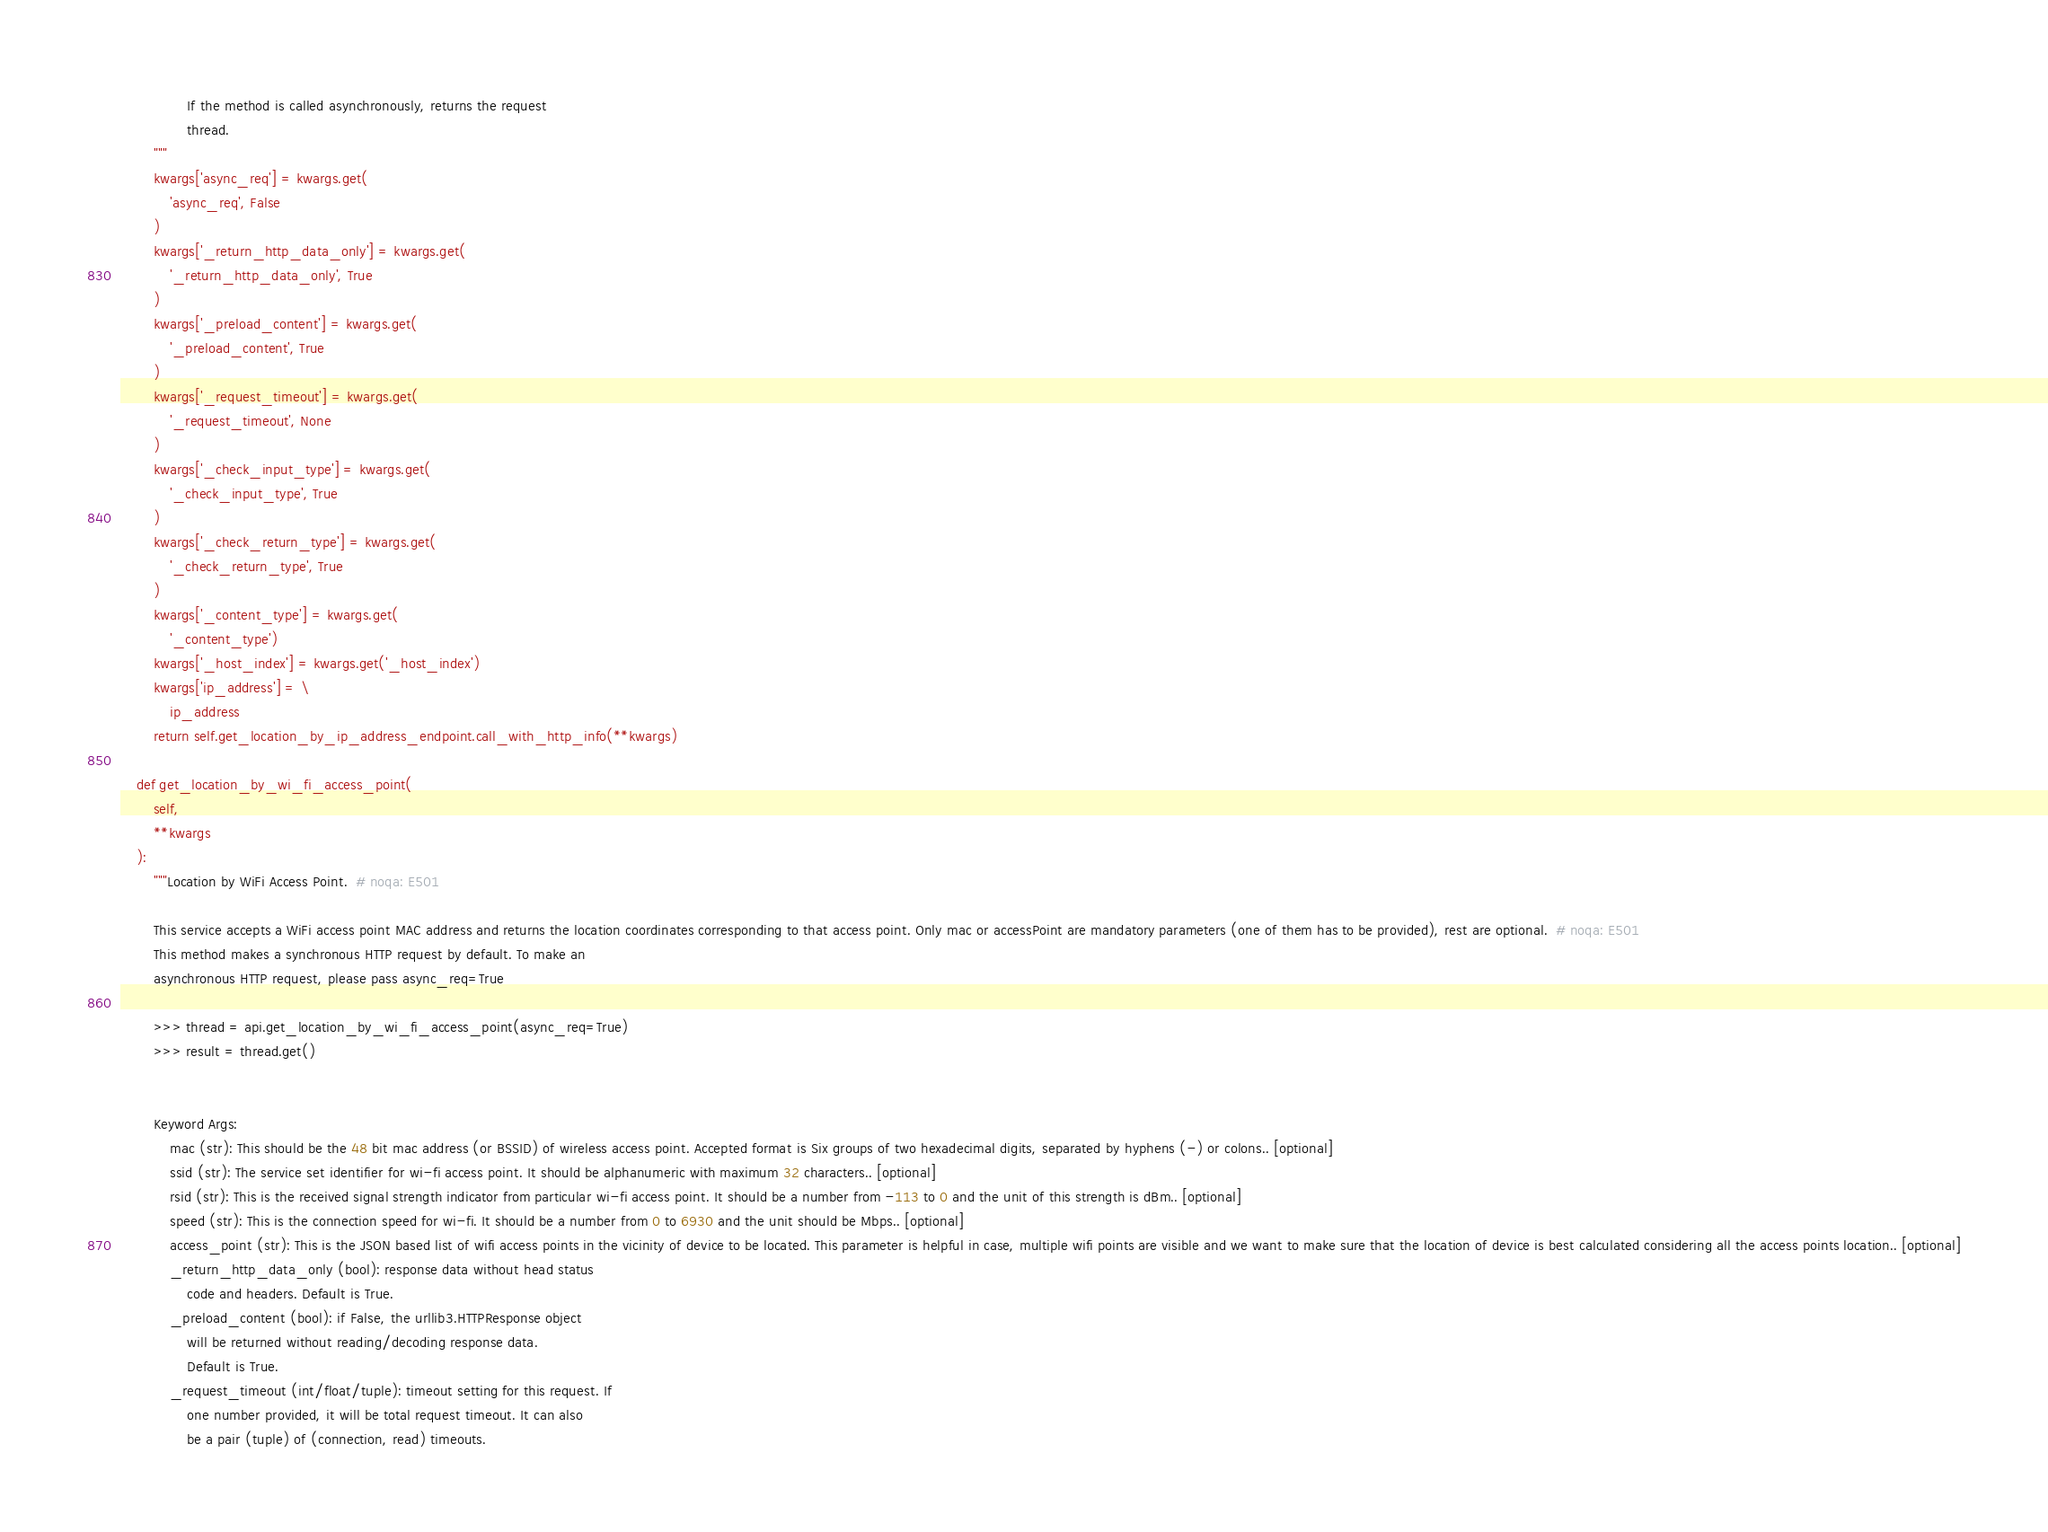Convert code to text. <code><loc_0><loc_0><loc_500><loc_500><_Python_>                If the method is called asynchronously, returns the request
                thread.
        """
        kwargs['async_req'] = kwargs.get(
            'async_req', False
        )
        kwargs['_return_http_data_only'] = kwargs.get(
            '_return_http_data_only', True
        )
        kwargs['_preload_content'] = kwargs.get(
            '_preload_content', True
        )
        kwargs['_request_timeout'] = kwargs.get(
            '_request_timeout', None
        )
        kwargs['_check_input_type'] = kwargs.get(
            '_check_input_type', True
        )
        kwargs['_check_return_type'] = kwargs.get(
            '_check_return_type', True
        )
        kwargs['_content_type'] = kwargs.get(
            '_content_type')
        kwargs['_host_index'] = kwargs.get('_host_index')
        kwargs['ip_address'] = \
            ip_address
        return self.get_location_by_ip_address_endpoint.call_with_http_info(**kwargs)

    def get_location_by_wi_fi_access_point(
        self,
        **kwargs
    ):
        """Location by WiFi Access Point.  # noqa: E501

        This service accepts a WiFi access point MAC address and returns the location coordinates corresponding to that access point. Only mac or accessPoint are mandatory parameters (one of them has to be provided), rest are optional.  # noqa: E501
        This method makes a synchronous HTTP request by default. To make an
        asynchronous HTTP request, please pass async_req=True

        >>> thread = api.get_location_by_wi_fi_access_point(async_req=True)
        >>> result = thread.get()


        Keyword Args:
            mac (str): This should be the 48 bit mac address (or BSSID) of wireless access point. Accepted format is Six groups of two hexadecimal digits, separated by hyphens (-) or colons.. [optional]
            ssid (str): The service set identifier for wi-fi access point. It should be alphanumeric with maximum 32 characters.. [optional]
            rsid (str): This is the received signal strength indicator from particular wi-fi access point. It should be a number from -113 to 0 and the unit of this strength is dBm.. [optional]
            speed (str): This is the connection speed for wi-fi. It should be a number from 0 to 6930 and the unit should be Mbps.. [optional]
            access_point (str): This is the JSON based list of wifi access points in the vicinity of device to be located. This parameter is helpful in case, multiple wifi points are visible and we want to make sure that the location of device is best calculated considering all the access points location.. [optional]
            _return_http_data_only (bool): response data without head status
                code and headers. Default is True.
            _preload_content (bool): if False, the urllib3.HTTPResponse object
                will be returned without reading/decoding response data.
                Default is True.
            _request_timeout (int/float/tuple): timeout setting for this request. If
                one number provided, it will be total request timeout. It can also
                be a pair (tuple) of (connection, read) timeouts.</code> 